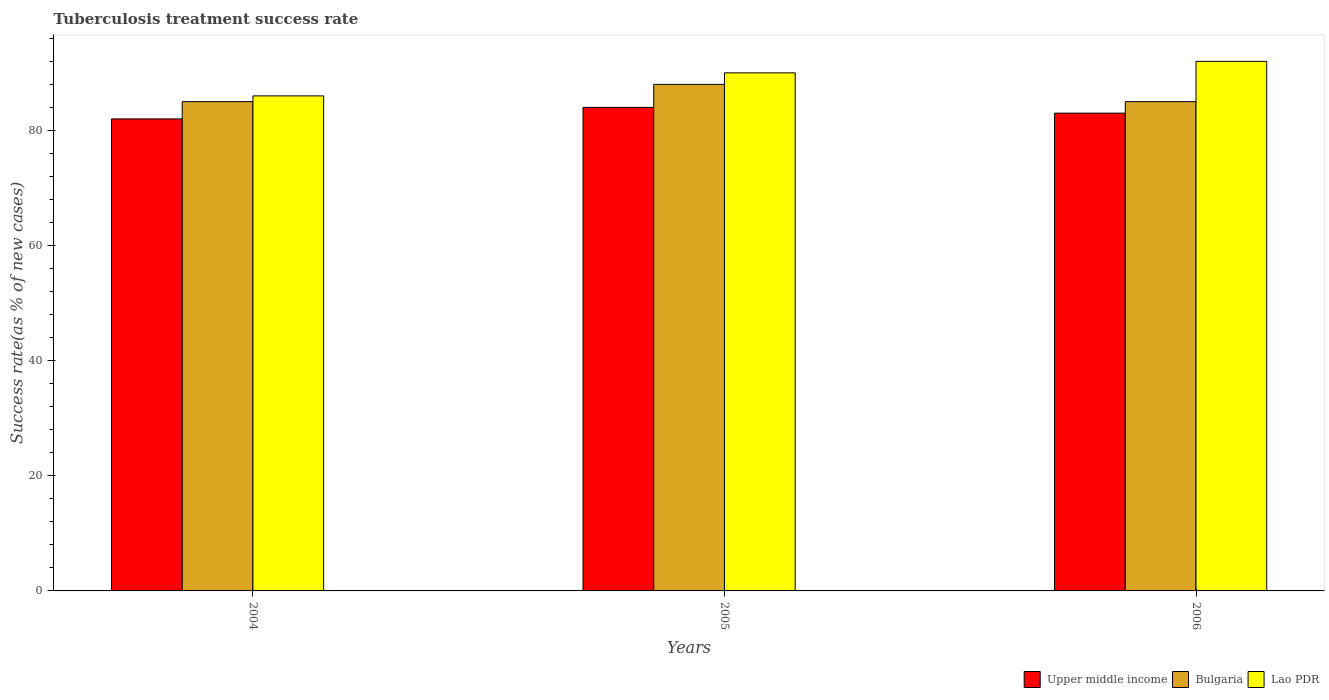How many groups of bars are there?
Keep it short and to the point. 3. Are the number of bars per tick equal to the number of legend labels?
Provide a succinct answer. Yes. Are the number of bars on each tick of the X-axis equal?
Provide a succinct answer. Yes. What is the label of the 3rd group of bars from the left?
Your answer should be compact. 2006. Across all years, what is the maximum tuberculosis treatment success rate in Bulgaria?
Make the answer very short. 88. Across all years, what is the minimum tuberculosis treatment success rate in Upper middle income?
Make the answer very short. 82. In which year was the tuberculosis treatment success rate in Upper middle income minimum?
Make the answer very short. 2004. What is the total tuberculosis treatment success rate in Upper middle income in the graph?
Provide a succinct answer. 249. What is the difference between the tuberculosis treatment success rate in Upper middle income in 2005 and that in 2006?
Your response must be concise. 1. What is the difference between the tuberculosis treatment success rate in Bulgaria in 2005 and the tuberculosis treatment success rate in Upper middle income in 2006?
Offer a very short reply. 5. What is the average tuberculosis treatment success rate in Lao PDR per year?
Your response must be concise. 89.33. In the year 2006, what is the difference between the tuberculosis treatment success rate in Upper middle income and tuberculosis treatment success rate in Lao PDR?
Give a very brief answer. -9. In how many years, is the tuberculosis treatment success rate in Lao PDR greater than 8 %?
Provide a succinct answer. 3. What is the ratio of the tuberculosis treatment success rate in Upper middle income in 2004 to that in 2006?
Keep it short and to the point. 0.99. Is the tuberculosis treatment success rate in Bulgaria in 2004 less than that in 2006?
Your response must be concise. No. What is the difference between the highest and the lowest tuberculosis treatment success rate in Bulgaria?
Make the answer very short. 3. In how many years, is the tuberculosis treatment success rate in Upper middle income greater than the average tuberculosis treatment success rate in Upper middle income taken over all years?
Provide a short and direct response. 1. What does the 3rd bar from the left in 2006 represents?
Offer a very short reply. Lao PDR. What does the 3rd bar from the right in 2006 represents?
Provide a succinct answer. Upper middle income. How many years are there in the graph?
Ensure brevity in your answer.  3. Does the graph contain any zero values?
Ensure brevity in your answer.  No. Where does the legend appear in the graph?
Your answer should be very brief. Bottom right. How many legend labels are there?
Provide a succinct answer. 3. How are the legend labels stacked?
Provide a succinct answer. Horizontal. What is the title of the graph?
Ensure brevity in your answer.  Tuberculosis treatment success rate. What is the label or title of the X-axis?
Your answer should be compact. Years. What is the label or title of the Y-axis?
Provide a short and direct response. Success rate(as % of new cases). What is the Success rate(as % of new cases) of Upper middle income in 2004?
Provide a succinct answer. 82. What is the Success rate(as % of new cases) of Lao PDR in 2004?
Keep it short and to the point. 86. What is the Success rate(as % of new cases) of Upper middle income in 2006?
Offer a very short reply. 83. What is the Success rate(as % of new cases) in Lao PDR in 2006?
Make the answer very short. 92. Across all years, what is the maximum Success rate(as % of new cases) in Lao PDR?
Give a very brief answer. 92. Across all years, what is the minimum Success rate(as % of new cases) in Upper middle income?
Your answer should be compact. 82. Across all years, what is the minimum Success rate(as % of new cases) in Bulgaria?
Provide a short and direct response. 85. Across all years, what is the minimum Success rate(as % of new cases) in Lao PDR?
Make the answer very short. 86. What is the total Success rate(as % of new cases) in Upper middle income in the graph?
Keep it short and to the point. 249. What is the total Success rate(as % of new cases) in Bulgaria in the graph?
Make the answer very short. 258. What is the total Success rate(as % of new cases) of Lao PDR in the graph?
Your answer should be very brief. 268. What is the difference between the Success rate(as % of new cases) in Bulgaria in 2004 and that in 2005?
Your answer should be compact. -3. What is the difference between the Success rate(as % of new cases) of Upper middle income in 2004 and that in 2006?
Your answer should be very brief. -1. What is the difference between the Success rate(as % of new cases) of Lao PDR in 2004 and that in 2006?
Give a very brief answer. -6. What is the difference between the Success rate(as % of new cases) of Upper middle income in 2004 and the Success rate(as % of new cases) of Bulgaria in 2005?
Your response must be concise. -6. What is the difference between the Success rate(as % of new cases) of Upper middle income in 2004 and the Success rate(as % of new cases) of Lao PDR in 2005?
Offer a very short reply. -8. What is the difference between the Success rate(as % of new cases) of Bulgaria in 2004 and the Success rate(as % of new cases) of Lao PDR in 2005?
Provide a short and direct response. -5. What is the difference between the Success rate(as % of new cases) of Upper middle income in 2004 and the Success rate(as % of new cases) of Bulgaria in 2006?
Your answer should be very brief. -3. What is the difference between the Success rate(as % of new cases) of Upper middle income in 2005 and the Success rate(as % of new cases) of Lao PDR in 2006?
Make the answer very short. -8. What is the average Success rate(as % of new cases) in Bulgaria per year?
Your response must be concise. 86. What is the average Success rate(as % of new cases) of Lao PDR per year?
Keep it short and to the point. 89.33. In the year 2005, what is the difference between the Success rate(as % of new cases) of Upper middle income and Success rate(as % of new cases) of Bulgaria?
Your answer should be very brief. -4. In the year 2005, what is the difference between the Success rate(as % of new cases) in Upper middle income and Success rate(as % of new cases) in Lao PDR?
Keep it short and to the point. -6. What is the ratio of the Success rate(as % of new cases) in Upper middle income in 2004 to that in 2005?
Ensure brevity in your answer.  0.98. What is the ratio of the Success rate(as % of new cases) of Bulgaria in 2004 to that in 2005?
Your answer should be compact. 0.97. What is the ratio of the Success rate(as % of new cases) in Lao PDR in 2004 to that in 2005?
Offer a very short reply. 0.96. What is the ratio of the Success rate(as % of new cases) of Upper middle income in 2004 to that in 2006?
Provide a succinct answer. 0.99. What is the ratio of the Success rate(as % of new cases) of Lao PDR in 2004 to that in 2006?
Make the answer very short. 0.93. What is the ratio of the Success rate(as % of new cases) in Bulgaria in 2005 to that in 2006?
Ensure brevity in your answer.  1.04. What is the ratio of the Success rate(as % of new cases) of Lao PDR in 2005 to that in 2006?
Keep it short and to the point. 0.98. What is the difference between the highest and the second highest Success rate(as % of new cases) of Upper middle income?
Make the answer very short. 1. What is the difference between the highest and the lowest Success rate(as % of new cases) of Upper middle income?
Provide a short and direct response. 2. 